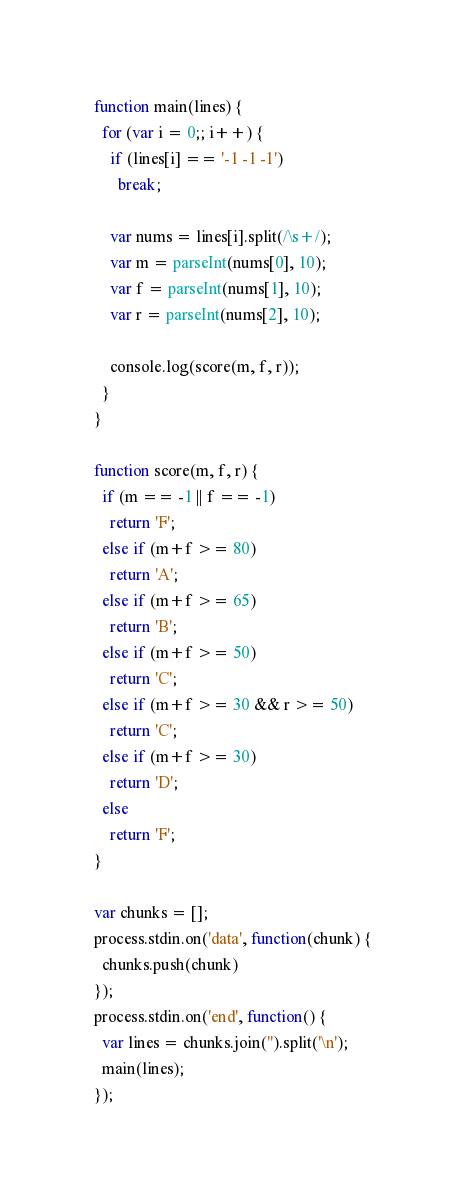<code> <loc_0><loc_0><loc_500><loc_500><_JavaScript_>function main(lines) {
  for (var i = 0;; i++) {
    if (lines[i] == '-1 -1 -1')
      break;

    var nums = lines[i].split(/\s+/);
    var m = parseInt(nums[0], 10);
    var f = parseInt(nums[1], 10);
    var r = parseInt(nums[2], 10);

    console.log(score(m, f, r));
  }
}

function score(m, f, r) {
  if (m == -1 || f == -1)
    return 'F';
  else if (m+f >= 80)
    return 'A';
  else if (m+f >= 65)
    return 'B';
  else if (m+f >= 50)
    return 'C';
  else if (m+f >= 30 && r >= 50)
    return 'C';
  else if (m+f >= 30)
    return 'D';
  else
    return 'F';
}

var chunks = [];
process.stdin.on('data', function(chunk) {
  chunks.push(chunk)
});
process.stdin.on('end', function() {
  var lines = chunks.join('').split('\n');
  main(lines);
});</code> 